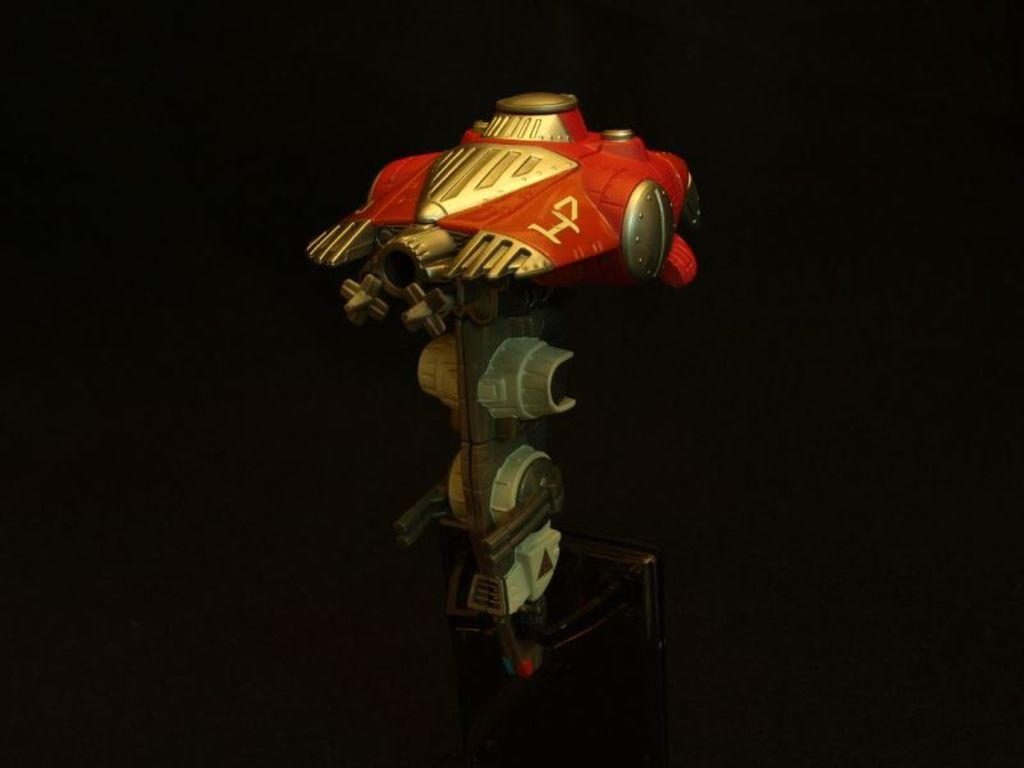What is the main subject of the image? There is an object in the image. Can you describe the colors of the object? The object has white, red, and gold colors. What can be observed about the background of the image? The background of the image is dark. What type of punishment is being depicted in the image? There is no indication of punishment in the image; it features an object with white, red, and gold colors against a dark background. How many ducks are visible in the image? There are no ducks present in the image. 